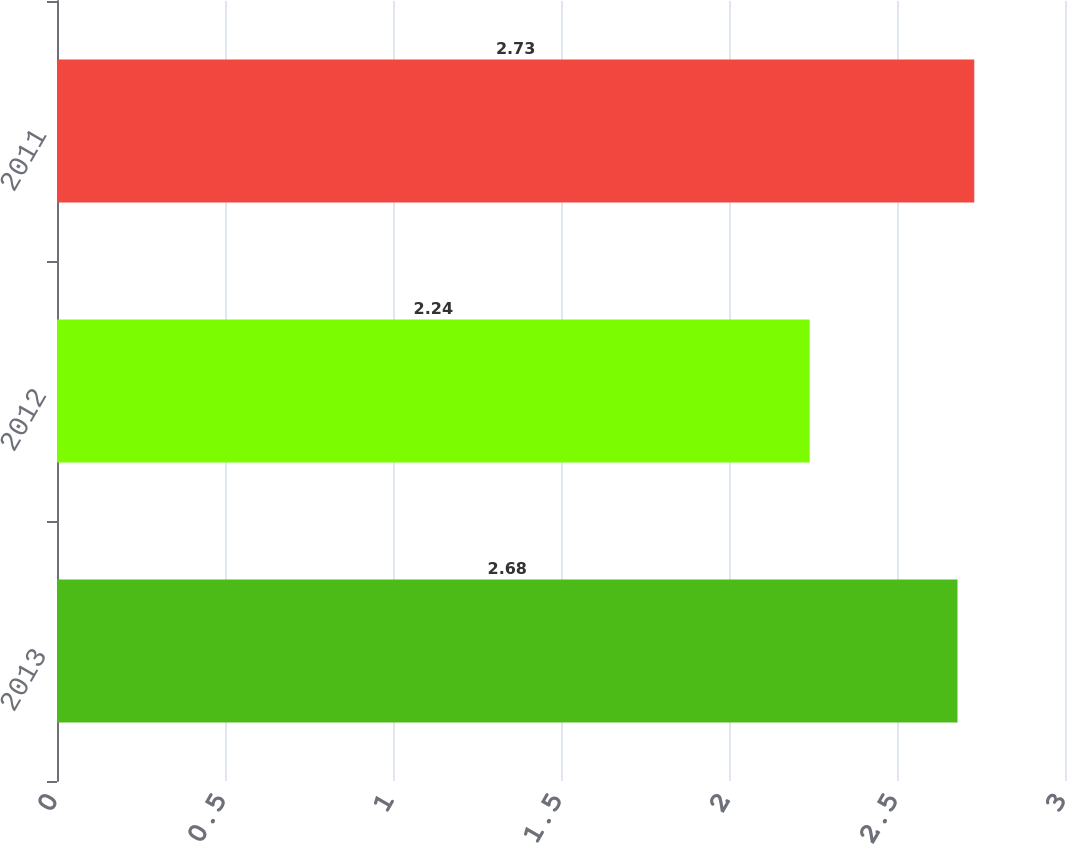<chart> <loc_0><loc_0><loc_500><loc_500><bar_chart><fcel>2013<fcel>2012<fcel>2011<nl><fcel>2.68<fcel>2.24<fcel>2.73<nl></chart> 